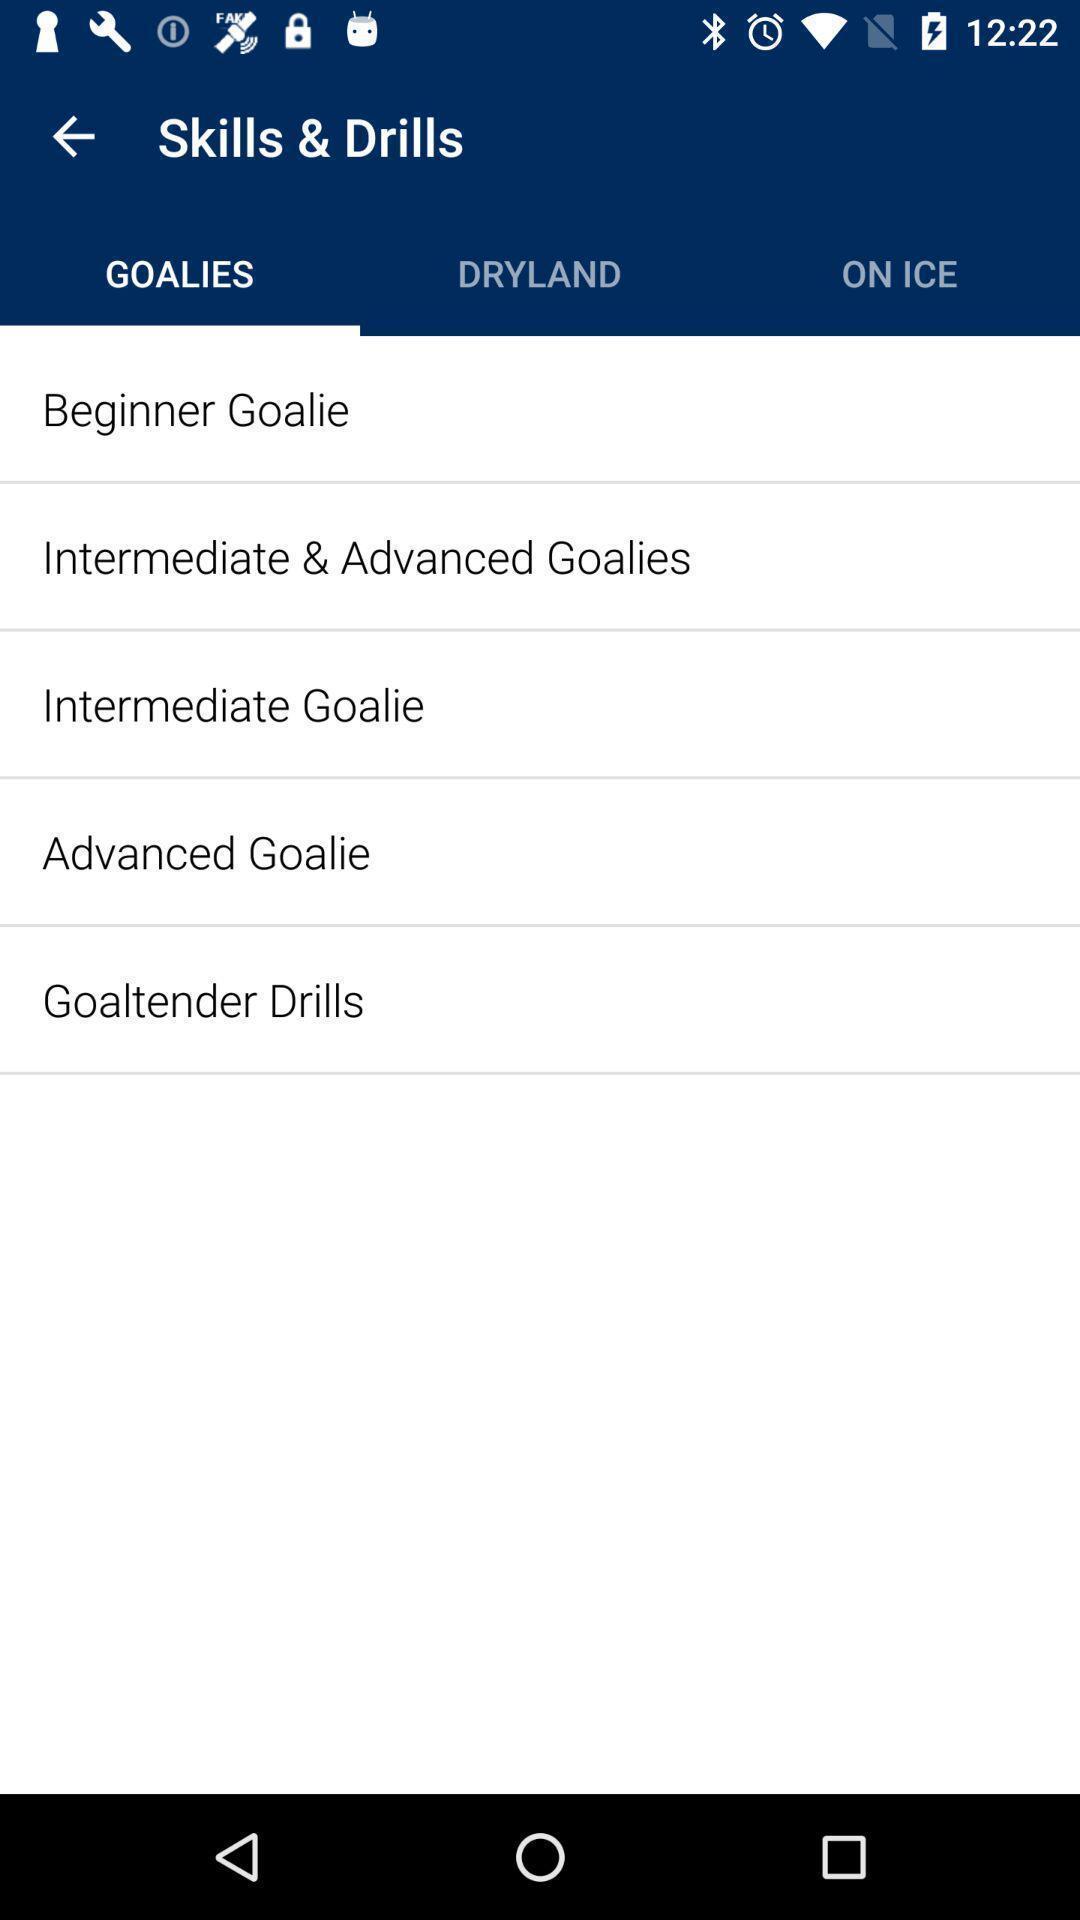Give me a summary of this screen capture. Screen shows skills and drills. 